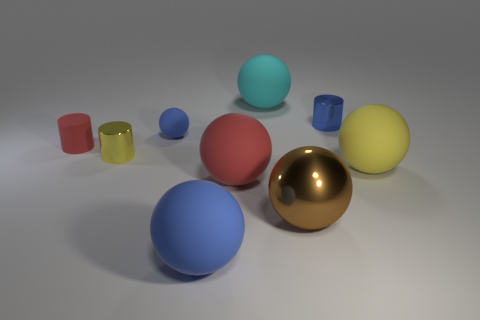What is the large thing that is on the left side of the metallic ball and in front of the big red matte object made of?
Offer a very short reply. Rubber. What size is the metallic cylinder that is behind the tiny matte cylinder that is in front of the large cyan rubber ball that is right of the small yellow object?
Provide a succinct answer. Small. Are there more large cyan rubber objects than gray metallic objects?
Make the answer very short. Yes. Is the blue thing that is behind the small rubber ball made of the same material as the yellow cylinder?
Provide a short and direct response. Yes. Are there fewer tiny blue balls than tiny yellow blocks?
Ensure brevity in your answer.  No. There is a small metallic cylinder that is on the right side of the cyan matte thing that is on the left side of the yellow matte thing; are there any large cyan spheres on the right side of it?
Offer a very short reply. No. Does the large yellow thing behind the big blue rubber thing have the same shape as the large shiny thing?
Ensure brevity in your answer.  Yes. Are there more small objects that are on the left side of the large cyan object than purple rubber cubes?
Offer a terse response. Yes. Is the color of the metal thing that is in front of the big red thing the same as the small matte cylinder?
Provide a succinct answer. No. Is there anything else that has the same color as the rubber cylinder?
Give a very brief answer. Yes. 